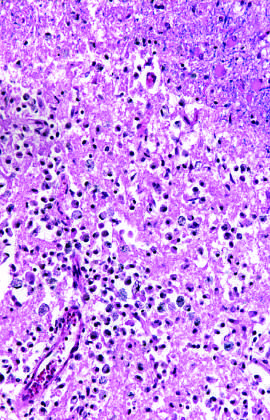by when does an area of infarction show the presence of macrophages and surrounding reactive gliosis?
Answer the question using a single word or phrase. Day 10 